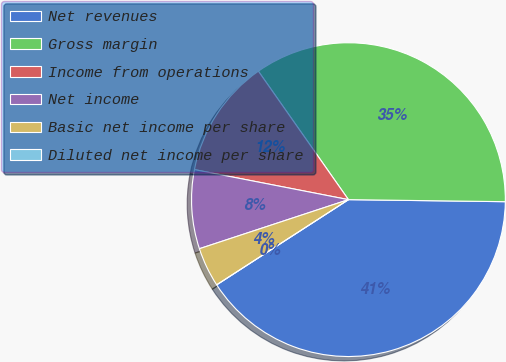Convert chart to OTSL. <chart><loc_0><loc_0><loc_500><loc_500><pie_chart><fcel>Net revenues<fcel>Gross margin<fcel>Income from operations<fcel>Net income<fcel>Basic net income per share<fcel>Diluted net income per share<nl><fcel>40.66%<fcel>34.94%<fcel>12.2%<fcel>8.13%<fcel>4.07%<fcel>0.0%<nl></chart> 